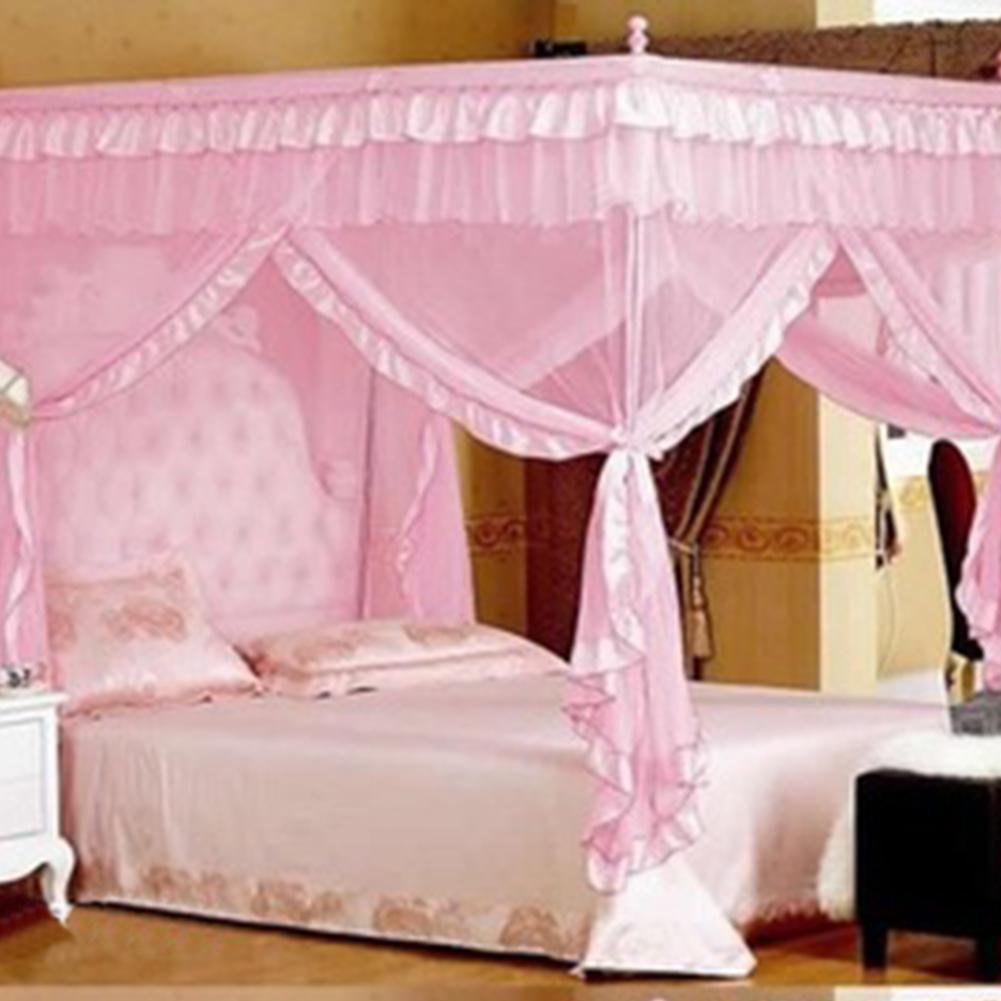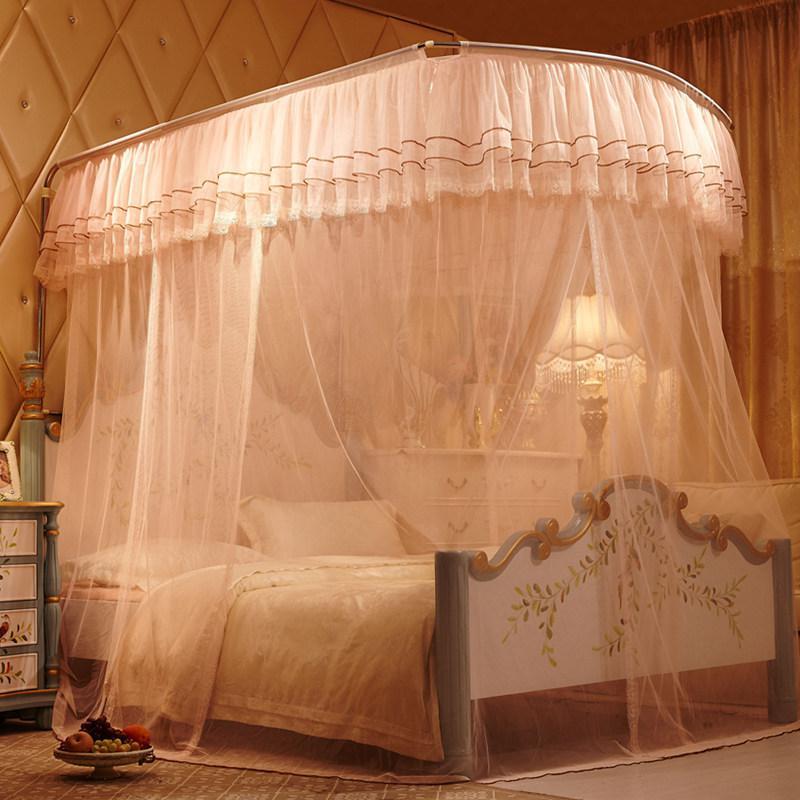The first image is the image on the left, the second image is the image on the right. Given the left and right images, does the statement "There is a pink canopy hanging over a bed" hold true? Answer yes or no. Yes. The first image is the image on the left, the second image is the image on the right. Given the left and right images, does the statement "The bed set in the left image has a pink canopy above it." hold true? Answer yes or no. Yes. 